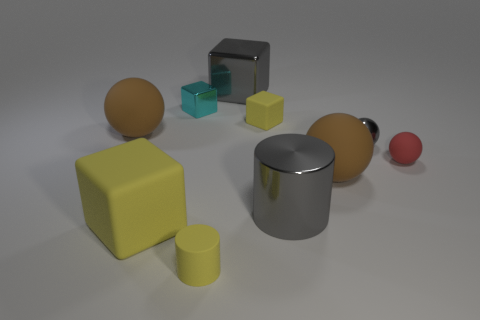There is a tiny metal sphere; is its color the same as the cube that is behind the cyan block?
Ensure brevity in your answer.  Yes. Are there fewer gray balls that are in front of the red rubber ball than shiny spheres that are behind the big yellow object?
Your answer should be compact. Yes. How many other things are there of the same shape as the tiny cyan thing?
Your answer should be very brief. 3. Is the number of large gray shiny things left of the small rubber cube less than the number of small objects?
Your answer should be very brief. Yes. What material is the cylinder in front of the big matte cube?
Provide a short and direct response. Rubber. How many other things are the same size as the yellow cylinder?
Provide a short and direct response. 4. Is the number of gray shiny cylinders less than the number of yellow rubber blocks?
Your answer should be very brief. Yes. There is a red thing; what shape is it?
Provide a short and direct response. Sphere. Do the small metal object right of the gray metal cube and the metal cylinder have the same color?
Offer a very short reply. Yes. What shape is the large thing that is both behind the tiny red thing and to the right of the yellow rubber cylinder?
Give a very brief answer. Cube. 